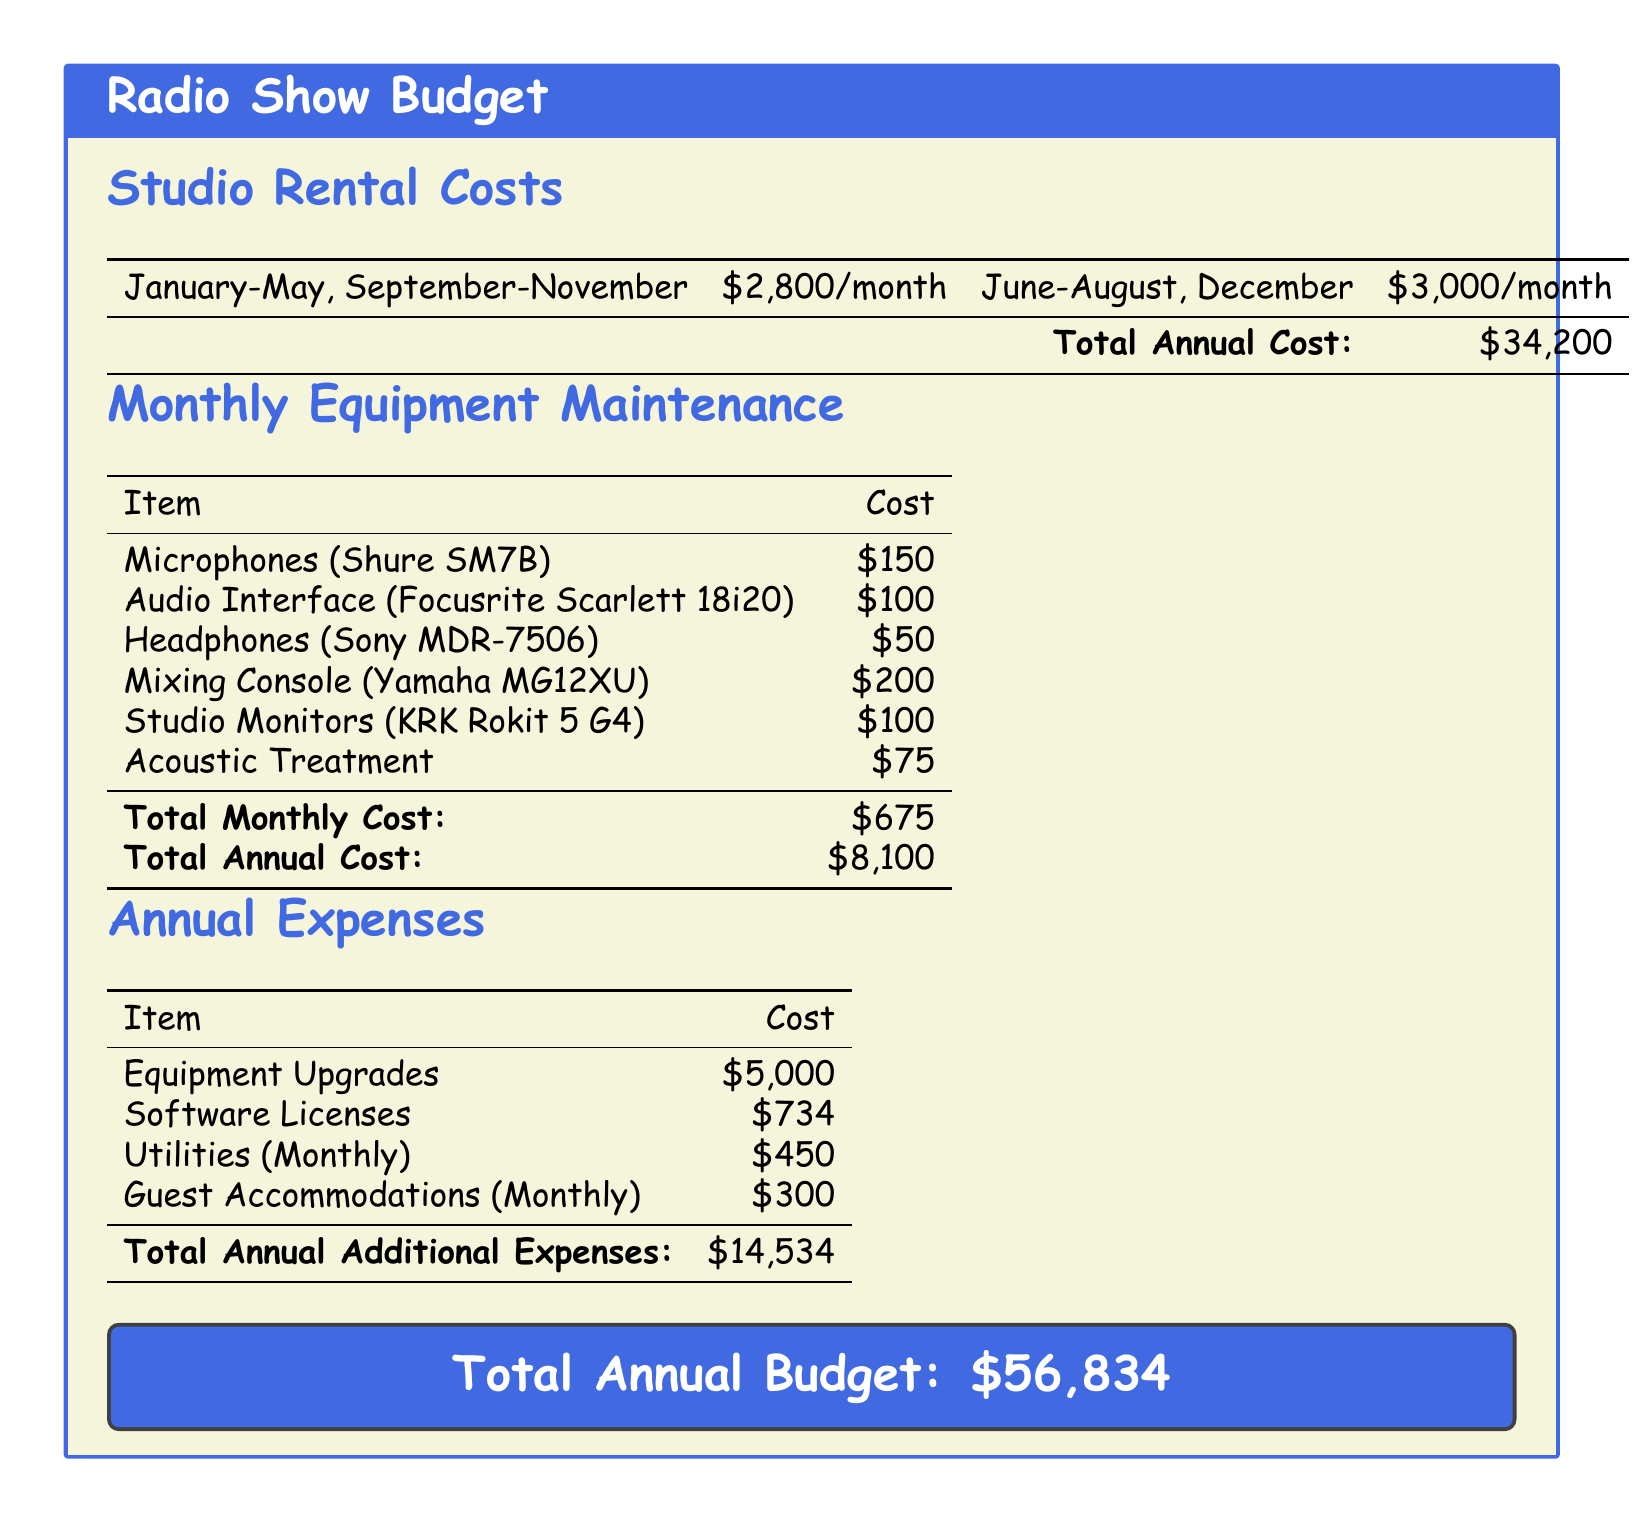What is the monthly cost for studio rental from January to May? The document specifies that the studio rental cost from January to May is $2,800 per month.
Answer: $2,800 What is the total annual cost of studio rentals? The total annual cost of studio rentals is mentioned as $34,200 in the document.
Answer: $34,200 How much does the Mixing Console cost? The cost of the Mixing Console (Yamaha MG12XU) is listed as $200.
Answer: $200 What is the total monthly cost for equipment maintenance? The document states that the total monthly cost for equipment maintenance is $675.
Answer: $675 What is the cost allocated for equipment upgrades annually? The document mentions that the cost for equipment upgrades is $5,000 annually.
Answer: $5,000 How much does Guest Accommodations cost per month? The monthly cost for guest accommodations is specified as $300.
Answer: $300 What is the total annual budget for the radio show? The total annual budget for the radio show is indicated as $56,834.
Answer: $56,834 Which item has the least cost in the Monthly Equipment Maintenance section? The item with the least cost in the Monthly Equipment Maintenance section is Headphones (Sony MDR-7506) at $50.
Answer: $50 What is the monthly cost for utilities? The document states the utilities cost is $450 per month.
Answer: $450 